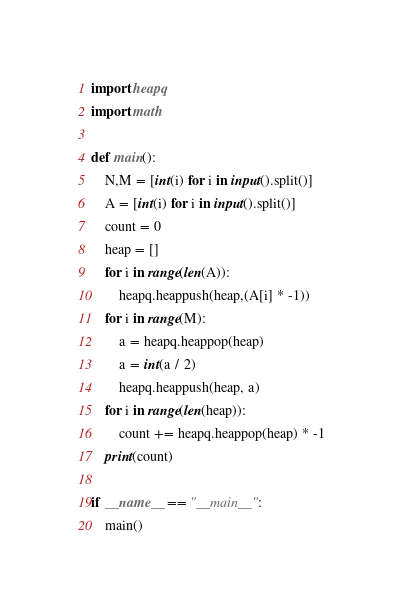<code> <loc_0><loc_0><loc_500><loc_500><_Python_>import heapq
import math

def main():
    N,M = [int(i) for i in input().split()]
    A = [int(i) for i in input().split()]
    count = 0
    heap = []
    for i in range(len(A)):
        heapq.heappush(heap,(A[i] * -1))
    for i in range(M):
        a = heapq.heappop(heap)
        a = int(a / 2)
        heapq.heappush(heap, a)
    for i in range(len(heap)):
        count += heapq.heappop(heap) * -1
    print(count)
    
if __name__ == "__main__":
    main()</code> 